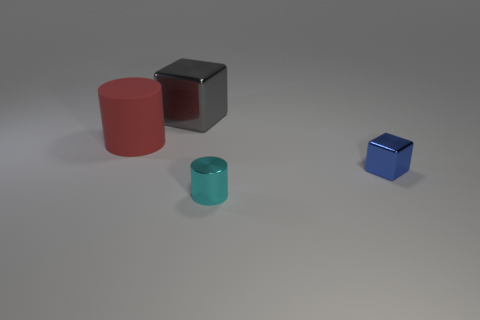Add 3 gray cubes. How many objects exist? 7 Add 4 tiny cylinders. How many tiny cylinders exist? 5 Subtract 1 red cylinders. How many objects are left? 3 Subtract all red objects. Subtract all gray shiny balls. How many objects are left? 3 Add 2 blue shiny blocks. How many blue shiny blocks are left? 3 